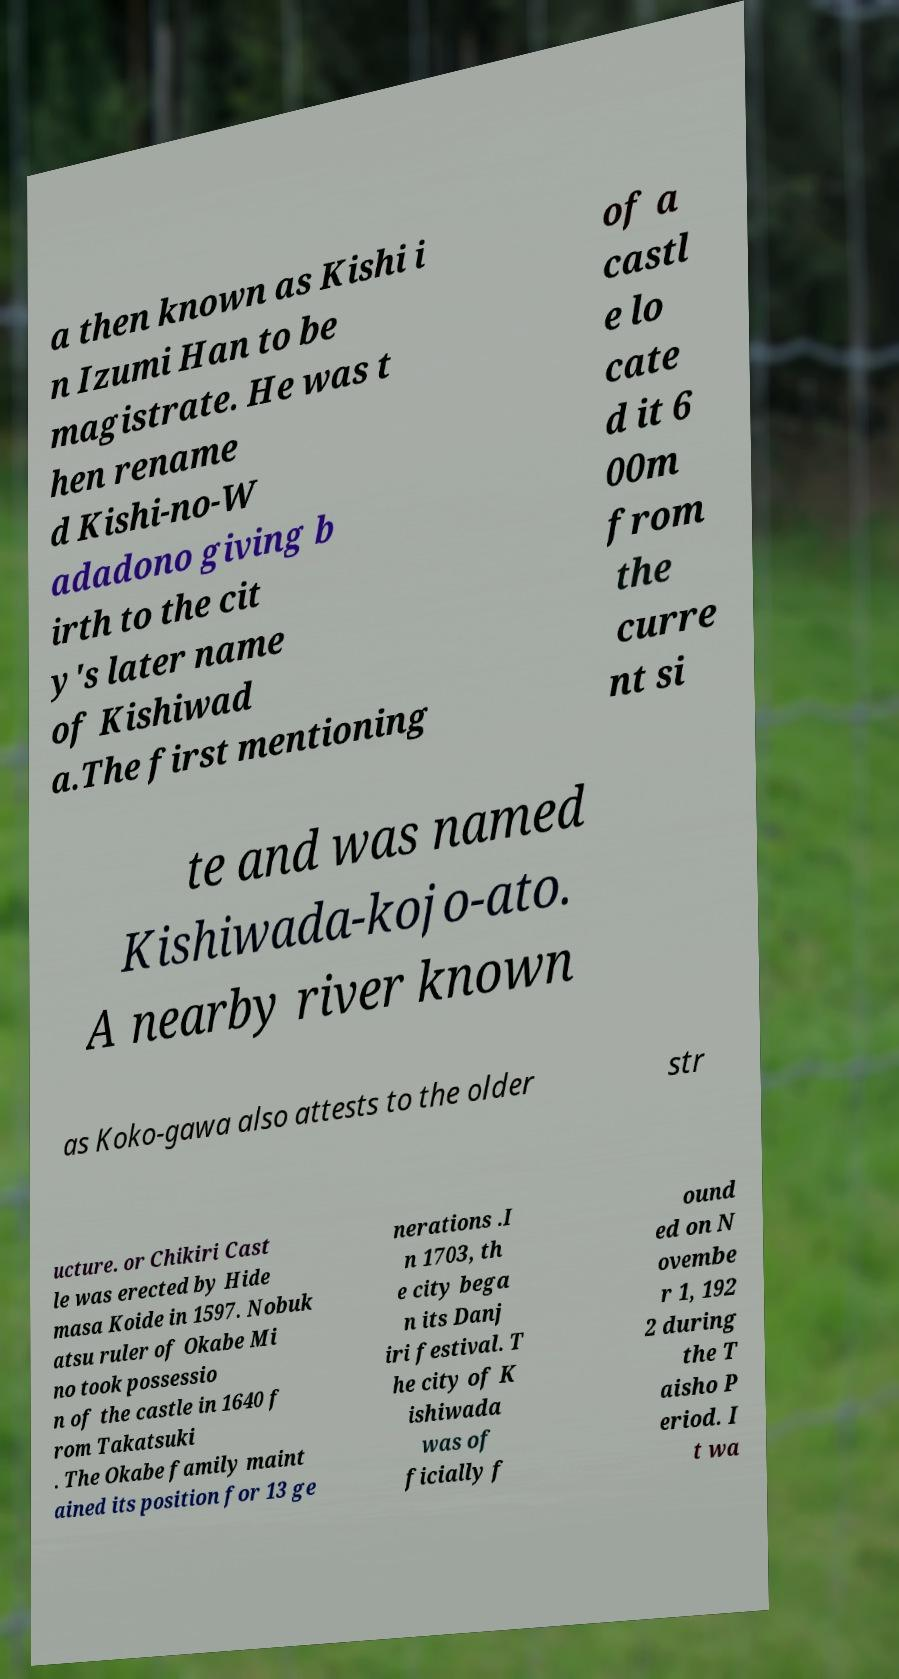Can you accurately transcribe the text from the provided image for me? a then known as Kishi i n Izumi Han to be magistrate. He was t hen rename d Kishi-no-W adadono giving b irth to the cit y's later name of Kishiwad a.The first mentioning of a castl e lo cate d it 6 00m from the curre nt si te and was named Kishiwada-kojo-ato. A nearby river known as Koko-gawa also attests to the older str ucture. or Chikiri Cast le was erected by Hide masa Koide in 1597. Nobuk atsu ruler of Okabe Mi no took possessio n of the castle in 1640 f rom Takatsuki . The Okabe family maint ained its position for 13 ge nerations .I n 1703, th e city bega n its Danj iri festival. T he city of K ishiwada was of ficially f ound ed on N ovembe r 1, 192 2 during the T aisho P eriod. I t wa 